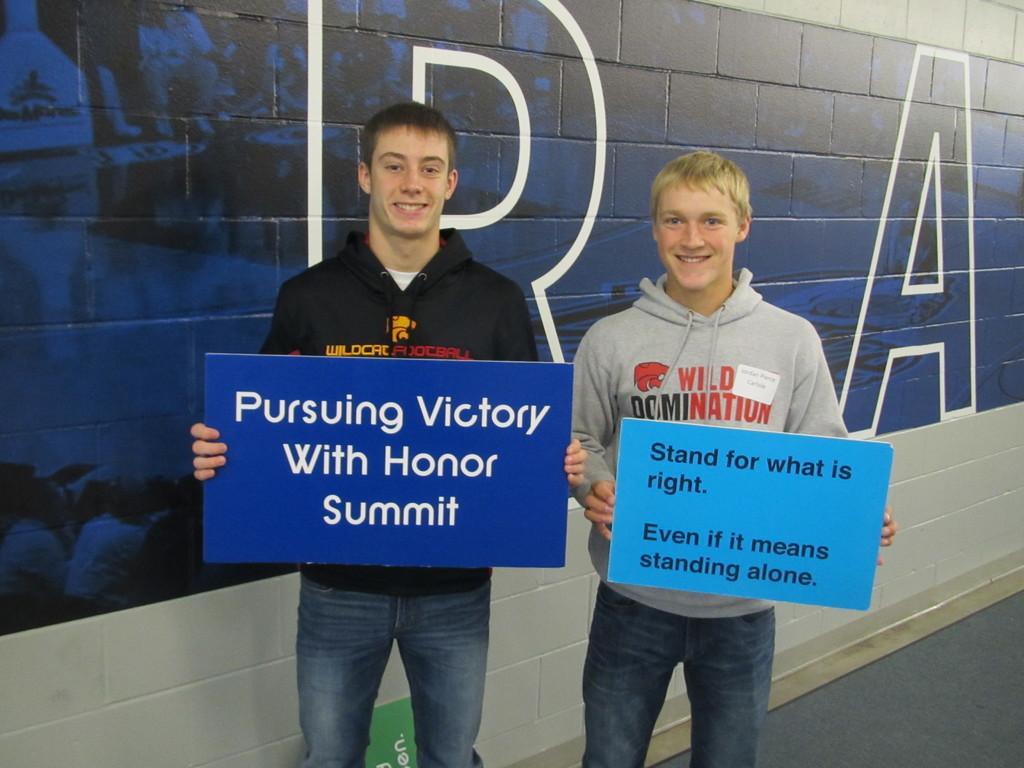Could you give a brief overview of what you see in this image? In this image we can see two men standing and holding boards with something written. In the back there is a wall with something written on that. 